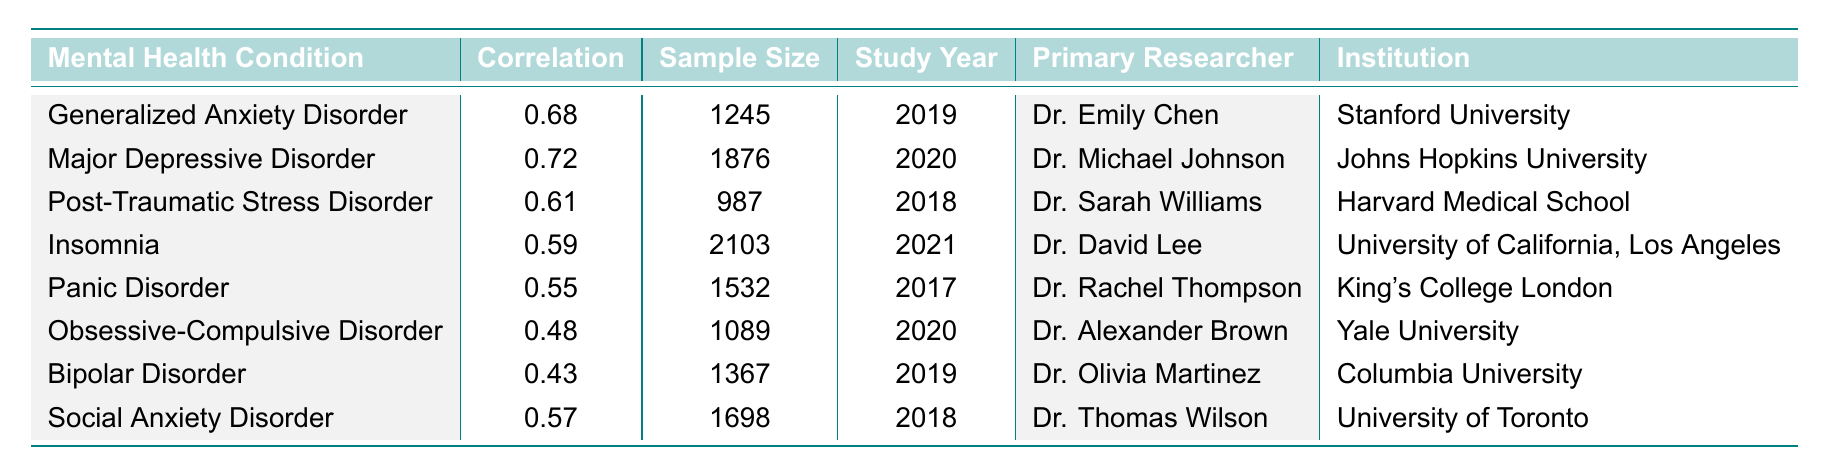What is the correlation coefficient for Major Depressive Disorder with chronic stress? The table lists Major Depressive Disorder with a correlation coefficient of 0.72 as per the corresponding row.
Answer: 0.72 Which mental health condition has the highest correlation with chronic stress? By examining the correlation coefficients in the table, Major Depressive Disorder has the highest value at 0.72.
Answer: Major Depressive Disorder How many samples were studied for Post-Traumatic Stress Disorder? The sample size for Post-Traumatic Stress Disorder is provided in the table, which states 987 participants were involved.
Answer: 987 What is the average correlation coefficient of all mental health conditions listed? To find the average, add the correlation coefficients: (0.68 + 0.72 + 0.61 + 0.59 + 0.55 + 0.48 + 0.43 + 0.57) = 4.63. There are 8 conditions, so the average is 4.63 / 8 = 0.57875, which can be rounded to 0.58.
Answer: 0.58 Is the correlation coefficient for Bipolar Disorder higher than that for Obsessive-Compulsive Disorder? Comparing the coefficients, Bipolar Disorder has 0.43 while Obsessive-Compulsive Disorder has 0.48. Since 0.43 is less than 0.48, the statement is false.
Answer: No Which institution is associated with the researcher who studied Generalized Anxiety Disorder? The table indicates that Dr. Emily Chen from Stanford University conducted the study on Generalized Anxiety Disorder.
Answer: Stanford University What is the difference in sample size between Insomnia and Panic Disorder studies? Insomnia has a sample size of 2103, and Panic Disorder has 1532. The difference is 2103 - 1532 = 571.
Answer: 571 List the mental health conditions studied in the year 2020. By checking the study year in the table, Major Depressive Disorder and Obsessive-Compulsive Disorder were both studied in 2020.
Answer: Major Depressive Disorder, Obsessive-Compulsive Disorder Which condition has a lower correlation, Social Anxiety Disorder or Insomnia? Social Anxiety Disorder has a correlation coefficient of 0.57, while Insomnia has 0.59. Since 0.57 is less than 0.59, Social Anxiety Disorder has a lower correlation.
Answer: Social Anxiety Disorder Which researcher studied the condition with the second-highest correlation with chronic stress? The second-highest correlation belongs to Generalized Anxiety Disorder at 0.68, studied by Dr. Emily Chen. Therefore, Dr. Emily Chen studied the condition with the second-highest correlation.
Answer: Dr. Emily Chen 